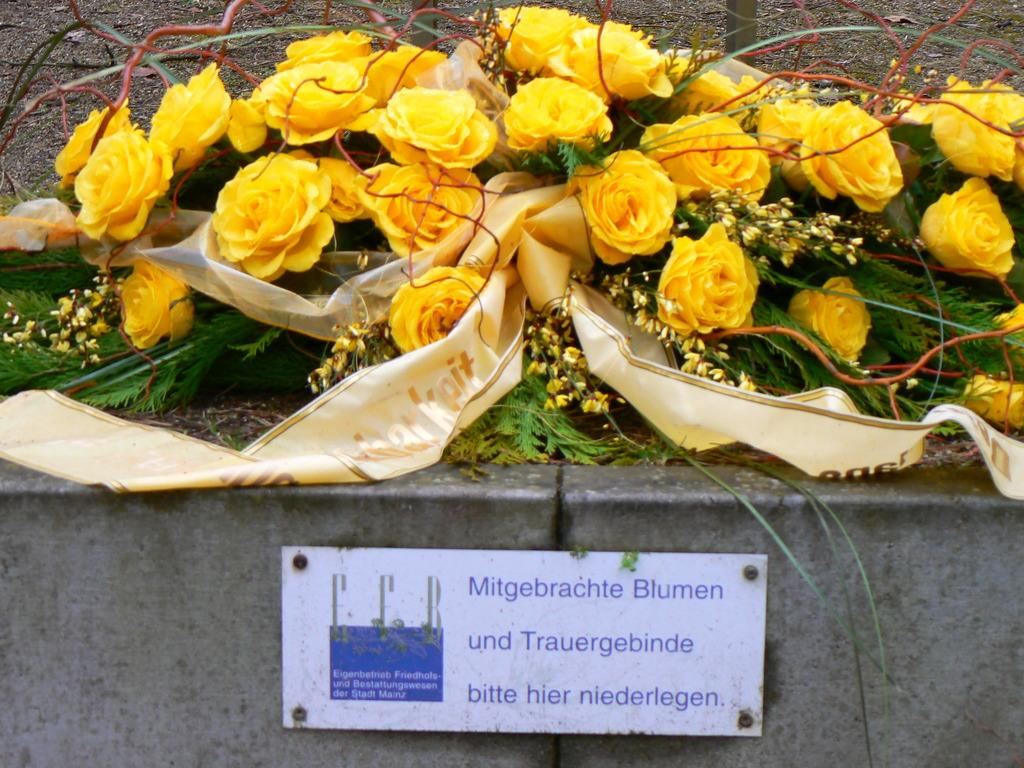What is on the wall in the image? There is a name board on the wall in the image. What can be seen in the background of the image? There are flowers and leaves in the background of the image. What type of guitar is the friend holding in the image? There is no guitar or friend present in the image; it only features a name board on the wall and flowers and leaves in the background. 